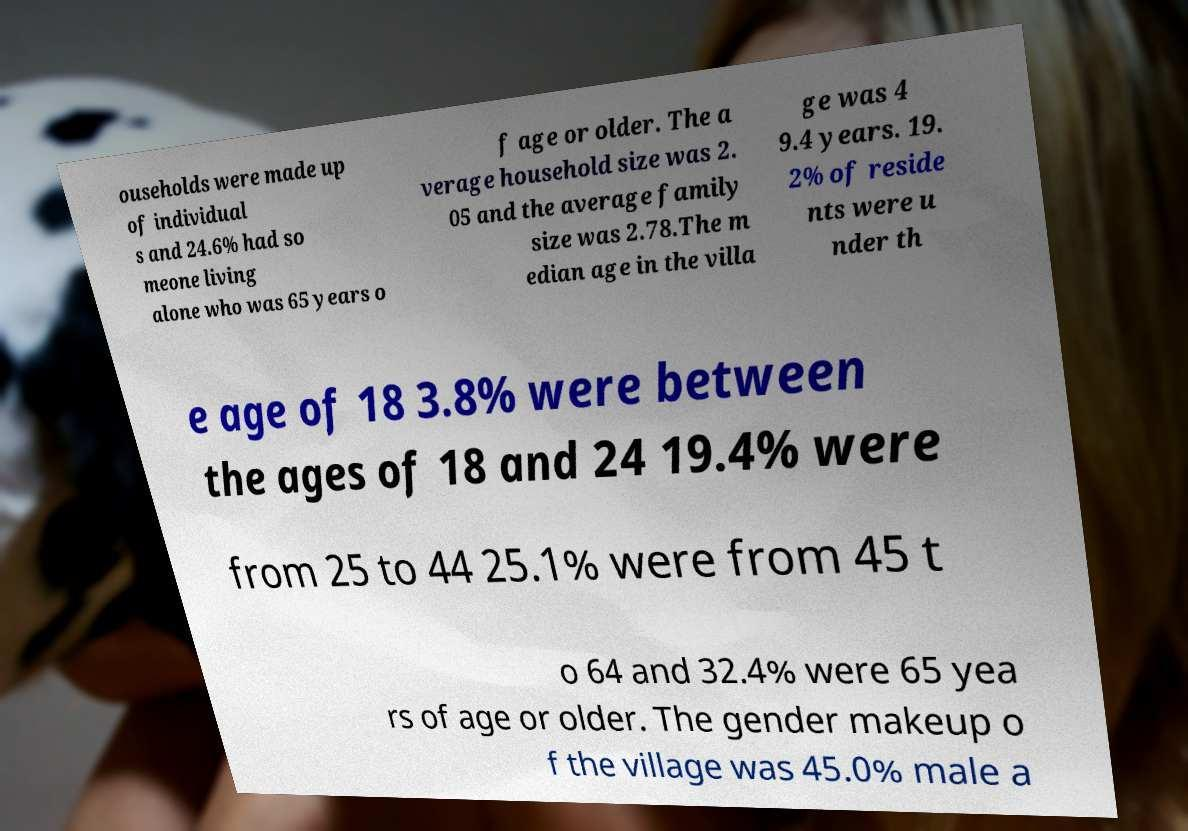I need the written content from this picture converted into text. Can you do that? ouseholds were made up of individual s and 24.6% had so meone living alone who was 65 years o f age or older. The a verage household size was 2. 05 and the average family size was 2.78.The m edian age in the villa ge was 4 9.4 years. 19. 2% of reside nts were u nder th e age of 18 3.8% were between the ages of 18 and 24 19.4% were from 25 to 44 25.1% were from 45 t o 64 and 32.4% were 65 yea rs of age or older. The gender makeup o f the village was 45.0% male a 